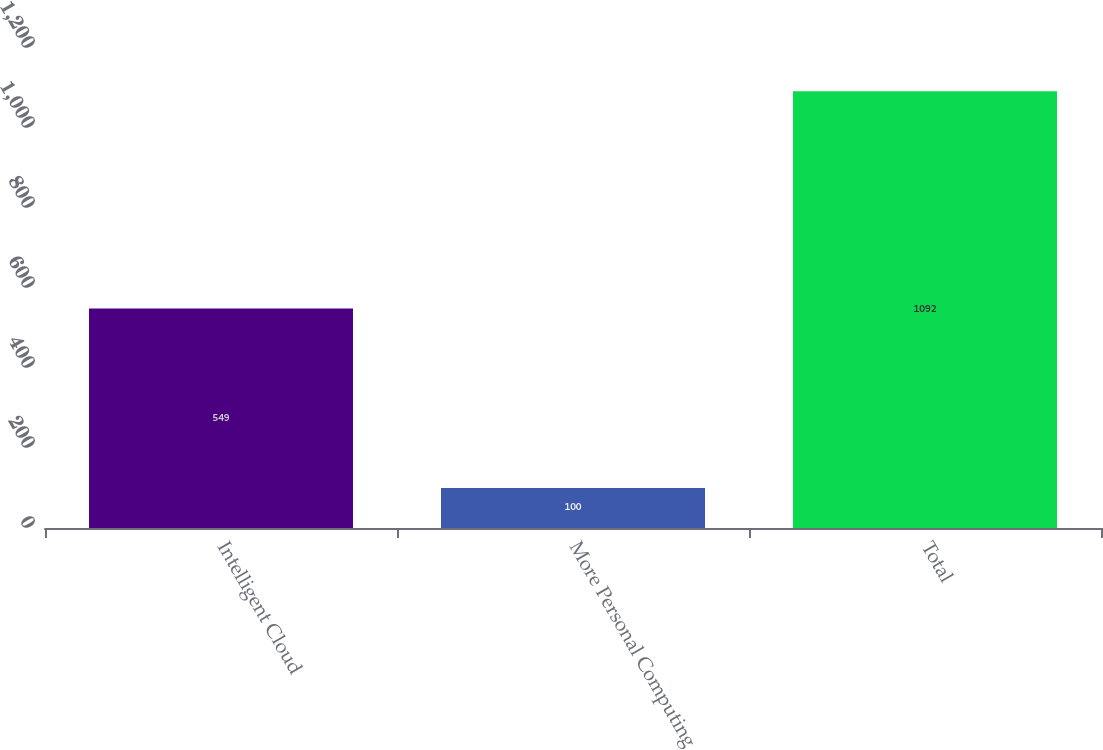Convert chart. <chart><loc_0><loc_0><loc_500><loc_500><bar_chart><fcel>Intelligent Cloud<fcel>More Personal Computing<fcel>Total<nl><fcel>549<fcel>100<fcel>1092<nl></chart> 